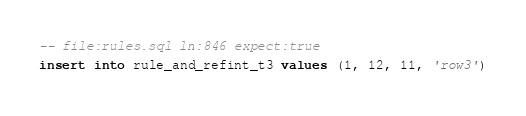Convert code to text. <code><loc_0><loc_0><loc_500><loc_500><_SQL_>-- file:rules.sql ln:846 expect:true
insert into rule_and_refint_t3 values (1, 12, 11, 'row3')
</code> 